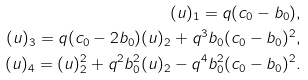Convert formula to latex. <formula><loc_0><loc_0><loc_500><loc_500>( u ) _ { 1 } = q ( c _ { 0 } - b _ { 0 } ) , \\ ( u ) _ { 3 } = q ( c _ { 0 } - 2 b _ { 0 } ) ( u ) _ { 2 } + q ^ { 3 } b _ { 0 } ( c _ { 0 } - b _ { 0 } ) ^ { 2 } , \\ ( u ) _ { 4 } = ( u ) _ { 2 } ^ { 2 } + q ^ { 2 } b _ { 0 } ^ { 2 } ( u ) _ { 2 } - q ^ { 4 } b _ { 0 } ^ { 2 } ( c _ { 0 } - b _ { 0 } ) ^ { 2 } .</formula> 